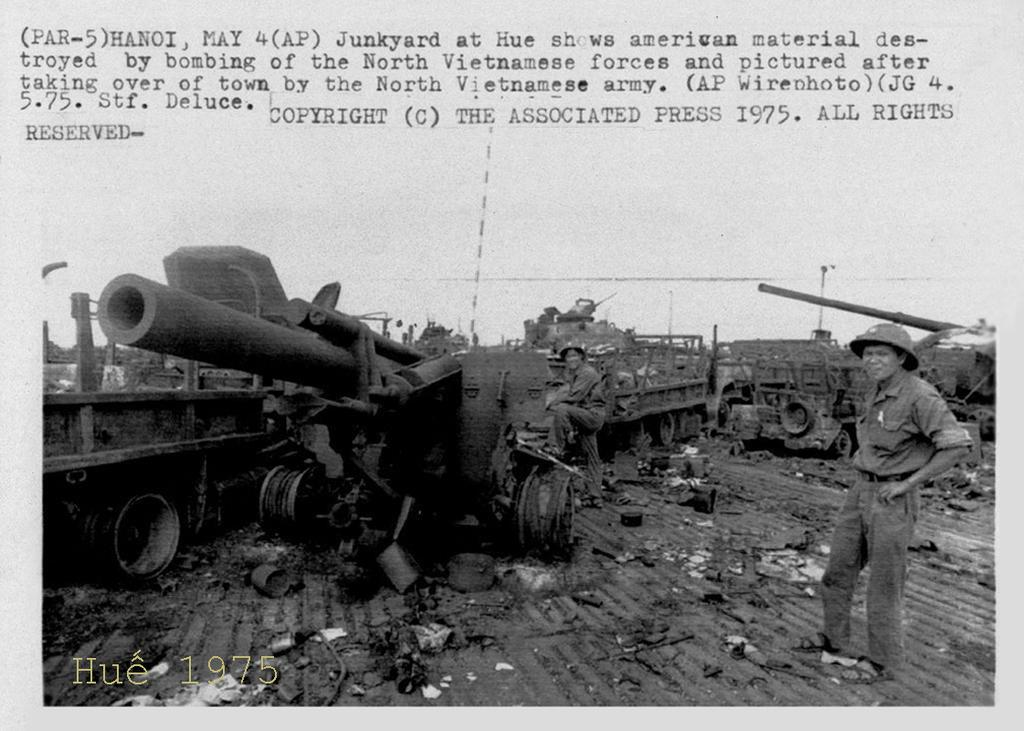Provide a one-sentence caption for the provided image. A group of brave soldiers around military equipment dated May 4th 1975. 